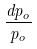<formula> <loc_0><loc_0><loc_500><loc_500>\frac { d p _ { o } } { p _ { o } }</formula> 